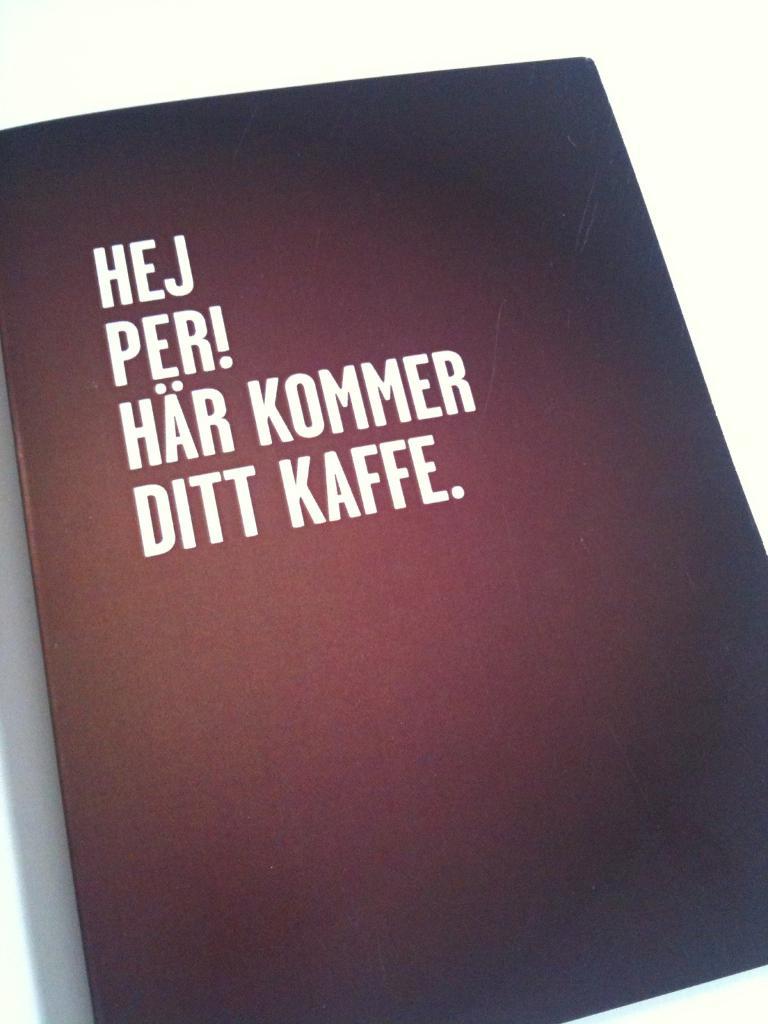What language is this book in?
Offer a terse response. Unanswerable. 